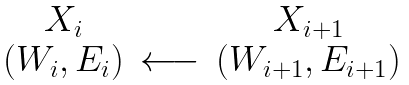Convert formula to latex. <formula><loc_0><loc_0><loc_500><loc_500>\begin{array} { c c c } X _ { i } & & X _ { i + 1 } \\ ( W _ { i } , E _ { i } ) & \longleftarrow & ( W _ { i + 1 } , E _ { i + 1 } ) \end{array}</formula> 